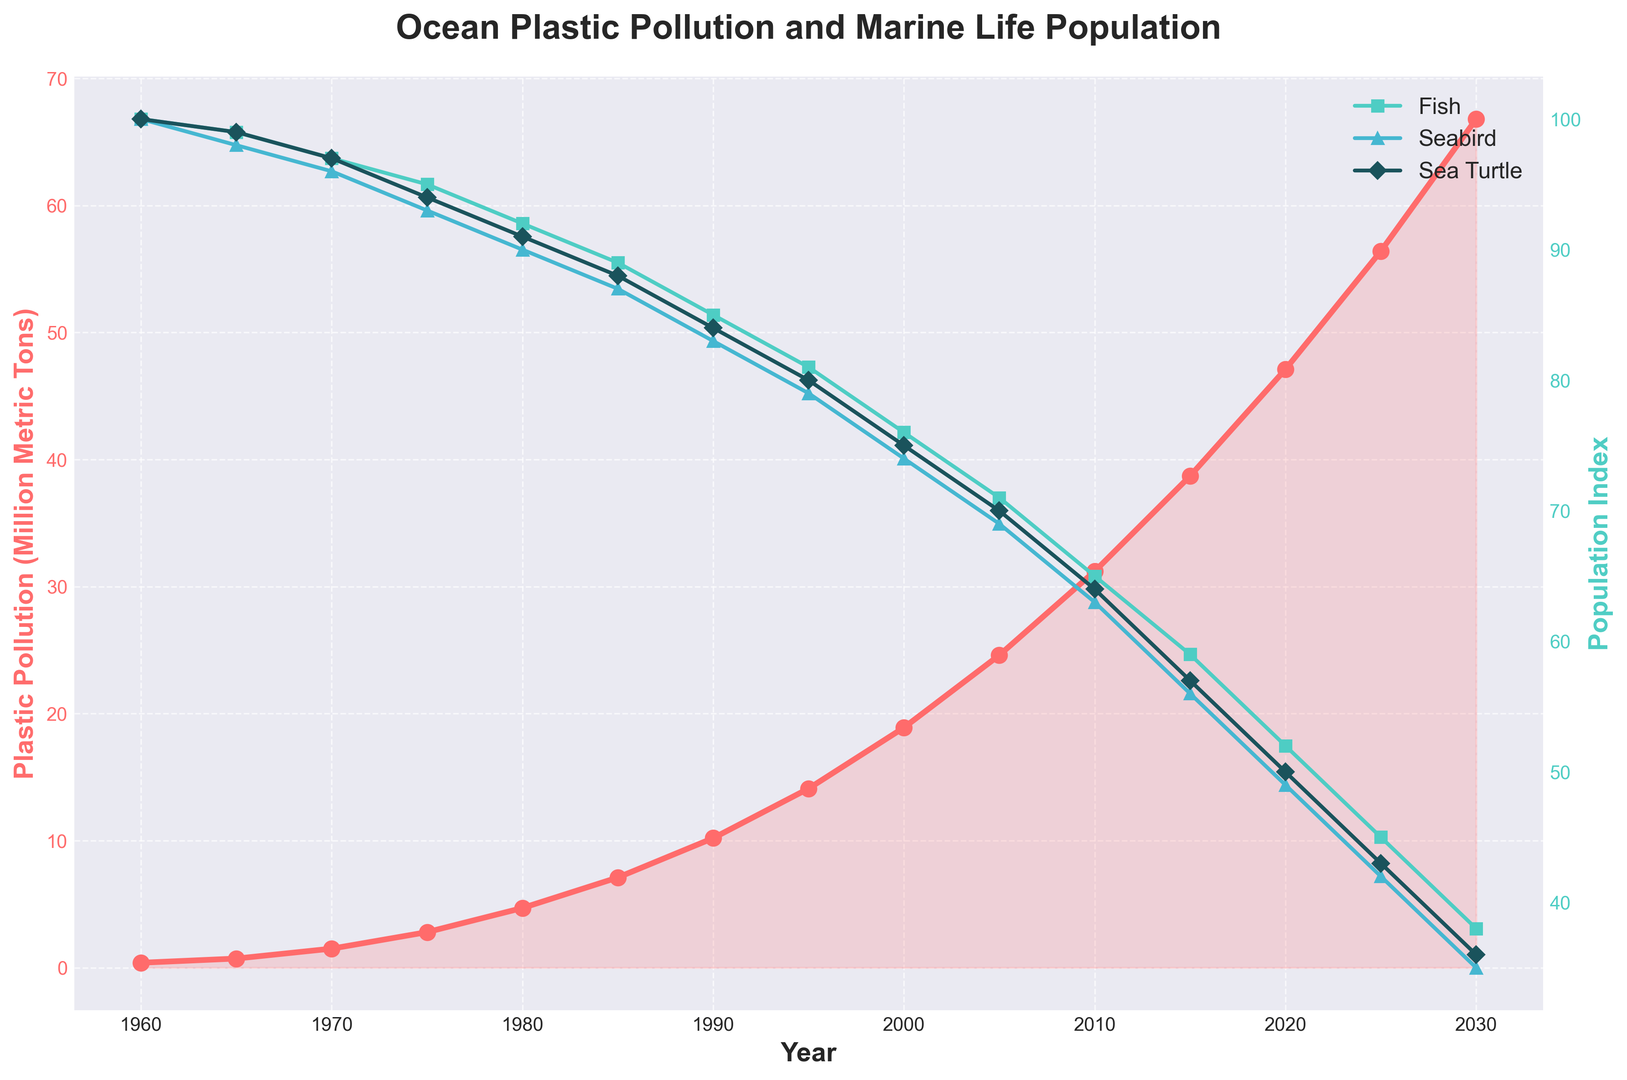How has the Sea Turtle Population Index changed from 1960 to 2030? In 1960, the Sea Turtle Population Index was 100. In 2030, it is projected to be 36. The change is calculated as 100 - 36 = 64.
Answer: Decreased by 64 Which year shows the highest plastic pollution level? The highest value plotted for plastic pollution is in 2030, with 66.8 million metric tons.
Answer: 2030 In which year do Fish, Seabird, and Sea Turtle population indices all intersect? There is no single year where all three indices exactly intersect according to the data and plotted lines.
Answer: No intersection How does the Seabird Population Index in 1980 compare to 2000? In 1980, the Seabird Population Index was 90. In 2000, it dropped to 74. The difference is 90 - 74 = 16.
Answer: Decreased by 16 What is the average Plastic Pollution level from 1960 to 1990? The Plastic Pollution levels from 1960 to 1990 are 0.39, 0.72, 1.5, 2.8, 4.7, 7.1, 10.2. The average is calculated as (0.39 + 0.72 + 1.5 + 2.8 + 4.7 + 7.1 + 10.2) / 7 = 4.48.
Answer: 4.48 million metric tons Which population index shows the greatest decline from 1960 to 2030? The Fish Population Index decreases from 100 to 38, a drop of 62. The Seabird Population Index decreases from 100 to 35, a drop of 65. The Sea Turtle Population Index decreases from 100 to 36, a drop of 64. The greatest decline is for the Seabird Population Index with a drop of 65.
Answer: Seabird Population Index How does the overall trend of plastic pollution compare to the trend in marine populations? The plastic pollution level consistently increases from 1960 to 2030, while all marine population indices (Fish, Seabird, Sea Turtle) show a consistent decline over the same period.
Answer: Inverse trends Which year shows the most significant reduction in the Fish Population Index? The most significant reduction in the Fish Population Index happens between 2015 and 2020, where the index drops from 59 to 52. The reduction is 59 - 52 = 7.
Answer: 2015 to 2020 By how much did the Seabird Population Index decrease from 2010 to 2020? In 2010, the Seabird Population Index was 63. In 2020, it was 49. The decrease is 63 - 49 = 14.
Answer: Decreased by 14 